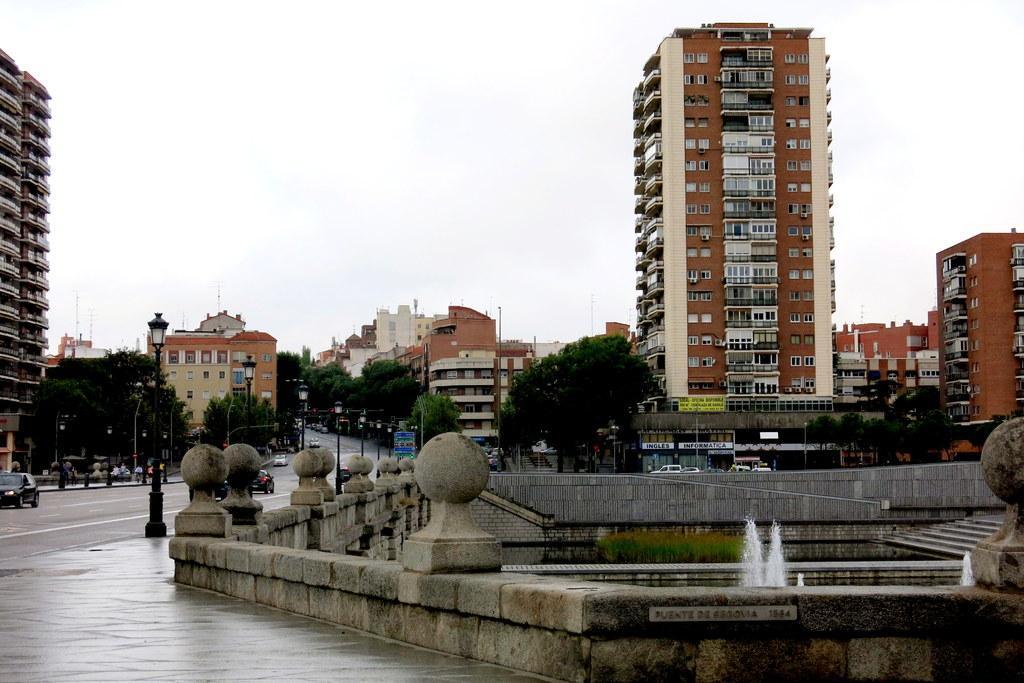In one or two sentences, can you explain what this image depicts? This is the picture of a place where we have some houses, buildings, trees, plants and also we can see some water fountain and some other things around. 